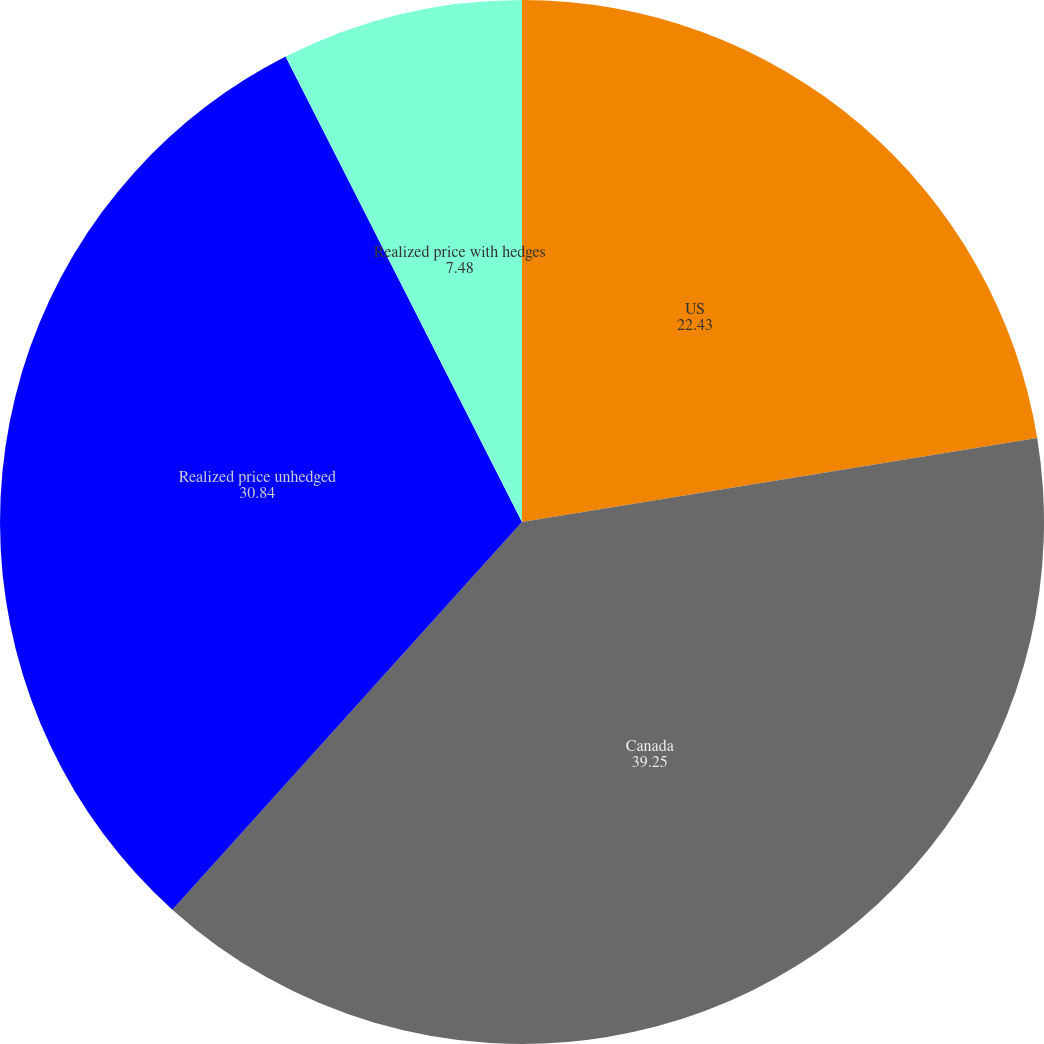Convert chart. <chart><loc_0><loc_0><loc_500><loc_500><pie_chart><fcel>US<fcel>Canada<fcel>Realized price unhedged<fcel>Realized price with hedges<nl><fcel>22.43%<fcel>39.25%<fcel>30.84%<fcel>7.48%<nl></chart> 